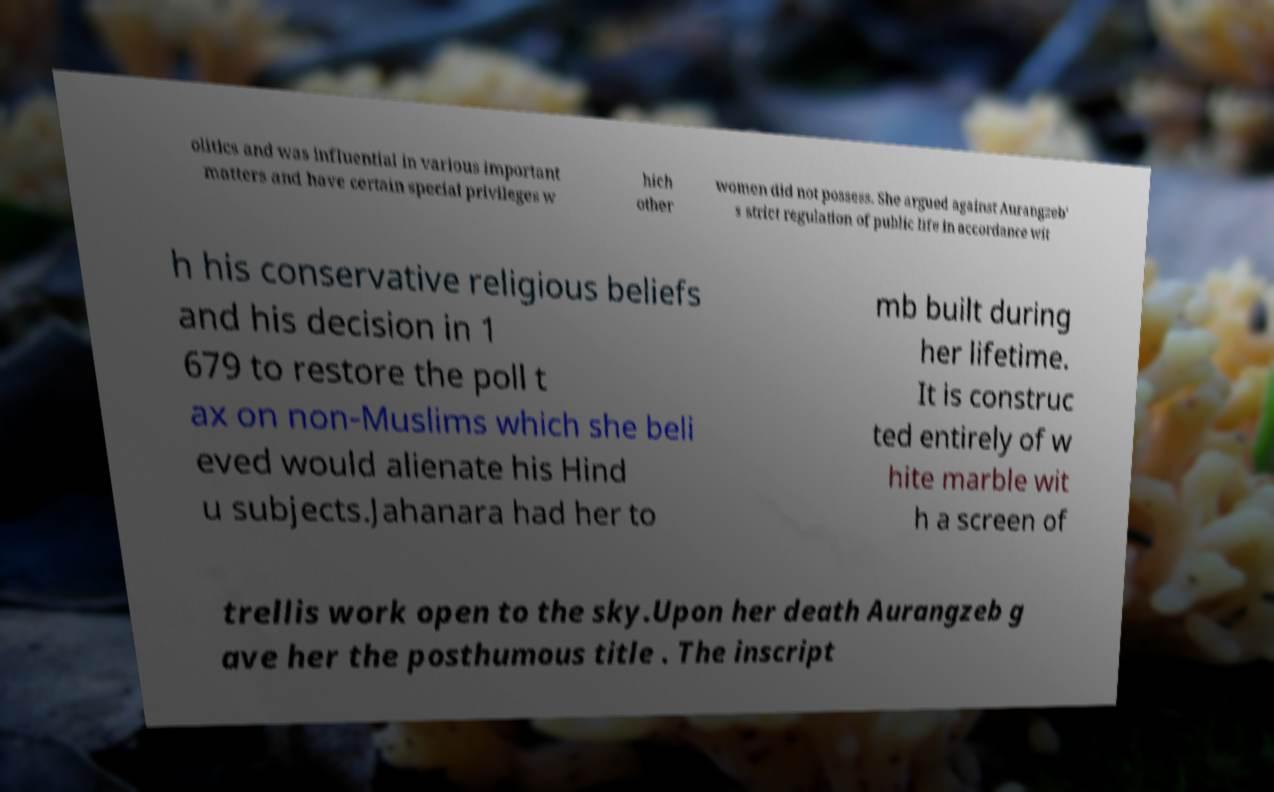Please read and relay the text visible in this image. What does it say? olitics and was influential in various important matters and have certain special privileges w hich other women did not possess. She argued against Aurangzeb' s strict regulation of public life in accordance wit h his conservative religious beliefs and his decision in 1 679 to restore the poll t ax on non-Muslims which she beli eved would alienate his Hind u subjects.Jahanara had her to mb built during her lifetime. It is construc ted entirely of w hite marble wit h a screen of trellis work open to the sky.Upon her death Aurangzeb g ave her the posthumous title . The inscript 